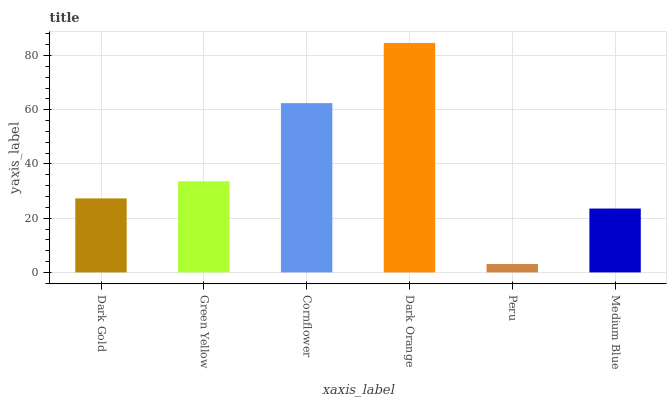Is Peru the minimum?
Answer yes or no. Yes. Is Dark Orange the maximum?
Answer yes or no. Yes. Is Green Yellow the minimum?
Answer yes or no. No. Is Green Yellow the maximum?
Answer yes or no. No. Is Green Yellow greater than Dark Gold?
Answer yes or no. Yes. Is Dark Gold less than Green Yellow?
Answer yes or no. Yes. Is Dark Gold greater than Green Yellow?
Answer yes or no. No. Is Green Yellow less than Dark Gold?
Answer yes or no. No. Is Green Yellow the high median?
Answer yes or no. Yes. Is Dark Gold the low median?
Answer yes or no. Yes. Is Cornflower the high median?
Answer yes or no. No. Is Cornflower the low median?
Answer yes or no. No. 